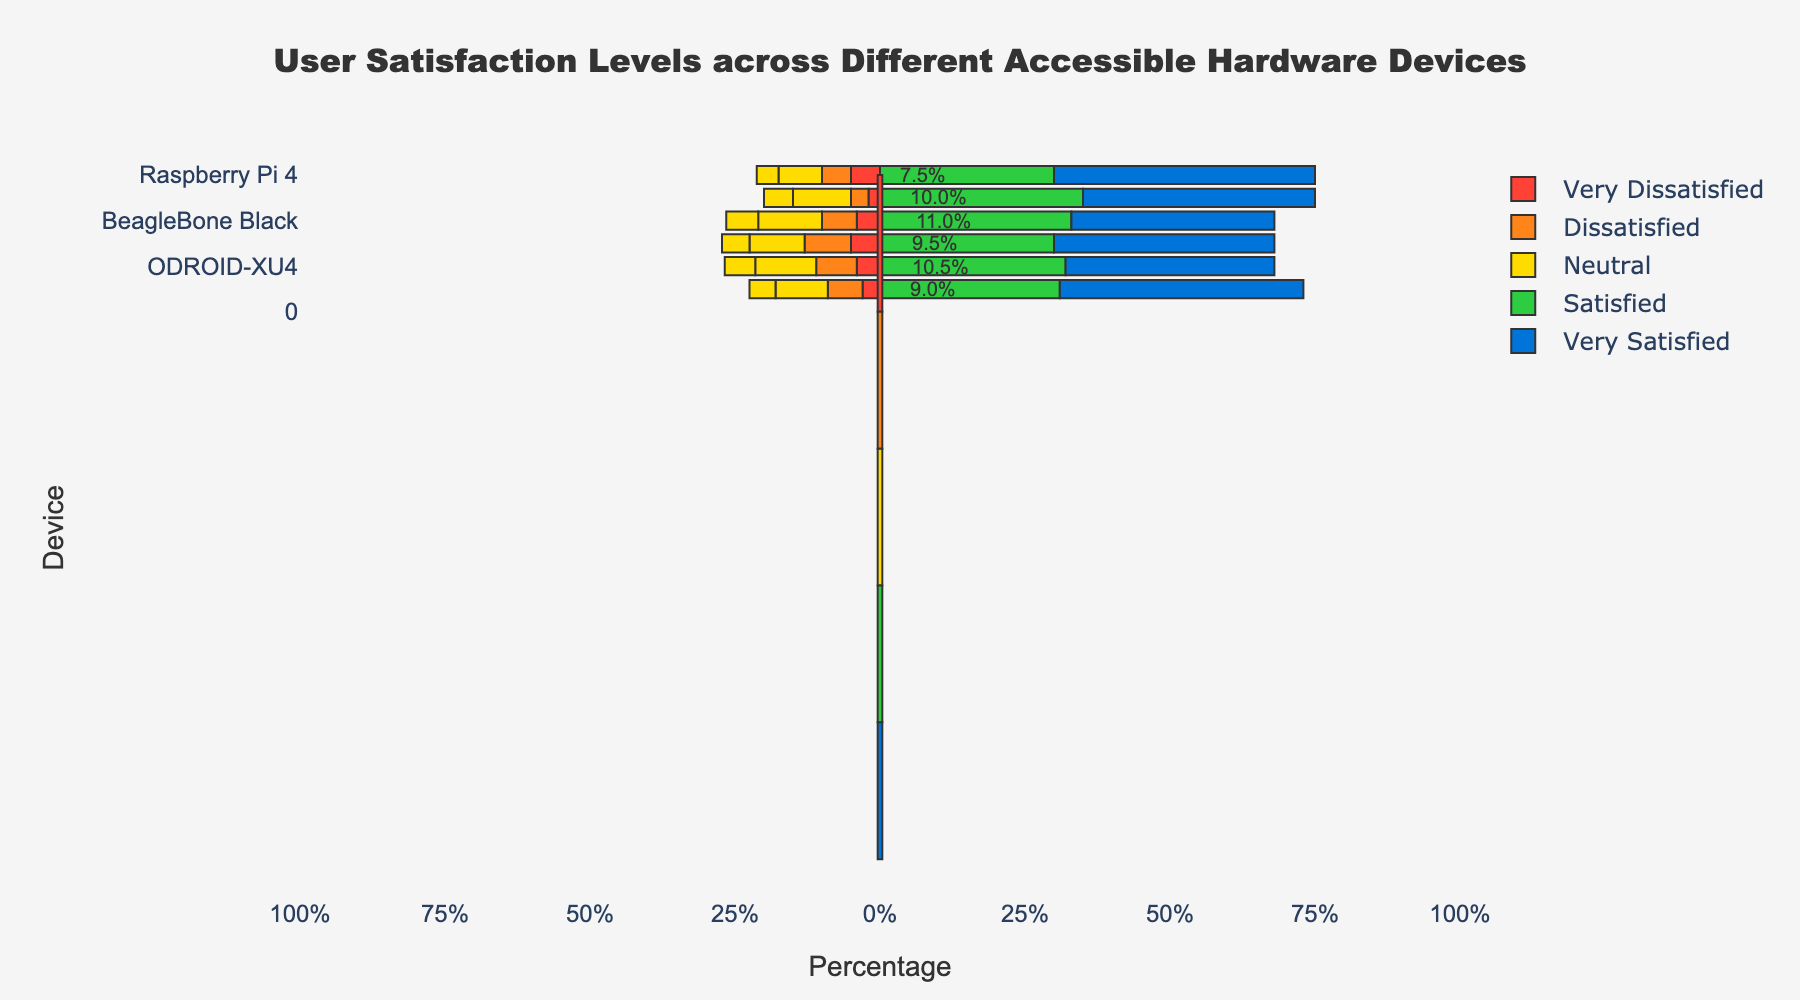Which device has the highest percentage of very satisfied users? To find the highest percentage of very satisfied users, look at the length of the blue bars for each device. The Raspberry Pi 4 has the longest blue bar indicating the highest percentage of very satisfied users.
Answer: Raspberry Pi 4 Compare the satisfaction levels (Very Satisfied + Satisfied) of Arduino Uno and Jetson Nano. Which one is higher? Add the percentages of very satisfied and satisfied users for both devices. Arduino Uno: Very Satisfied (40%) + Satisfied (35%) = 75%. Jetson Nano: Very Satisfied (42%) + Satisfied (31%) = 73%.
Answer: Arduino Uno What is the overall satisfaction (Very Satisfied + Satisfied) percentage for the Raspberry Pi 4 and BeagleBone Black combined? Add the percentages of very satisfied and satisfied users for both devices. Raspberry Pi 4: Very Satisfied (45%) + Satisfied (30%) = 75%. BeagleBone Black: Very Satisfied (35%) + Satisfied (33%) = 68%. Combined = 75% + 68% = 143%.
Answer: 143% Which device has the most neutral users? Identify the longest yellow bar representing neutral users. The BeagleBone Black has the longest yellow bar indicating the most neutral users.
Answer: BeagleBone Black What is the difference in the percentage of very dissatisfied users between Pinebook Pro and ODROID-XU4? Look at the length of the red bars for each device. Pinebook Pro: Very Dissatisfied (5%). ODROID-XU4: Very Dissatisfied (4%). Difference = 5% - 4% = 1%.
Answer: 1% Which two devices have the closest percentages of dissatisfied users? Compare the lengths of the orange bars indicating dissatisfied users. BeagleBone Black (6%) and Jetson Nano (6%) have the closest percentages.
Answer: BeagleBone Black and Jetson Nano Compare the levels of dissatisfaction (Dissatisfied + Very Dissatisfied) for the ODROID-XU4 and Raspberry Pi 4. Which one has higher levels of dissatisfaction? Add the percentages for dissatisfied and very dissatisfied users. ODROID-XU4: Dissatisfied (7%) + Very Dissatisfied (4%) = 11%. Raspberry Pi 4: Dissatisfied (5%) + Very Dissatisfied (5%) = 10%.
Answer: ODROID-XU4 What is the percentage range covered by the neutral users across all devices? Identify the minimum and maximum percentages for neutral users. Range spans from Arduino Uno (20%) to BeagleBone Black (22%).
Answer: 20% - 22% Calculate the percentage of dissatisfied and very dissatisfied users for all devices combined. Sum the percentages of dissatisfied and very dissatisfied users across all devices. Raspberry Pi 4: Dissatisfied (5%) + Very Dissatisfied (5%) = 10%. Arduino Uno: Dissatisfied (3%) + Very Dissatisfied (2%) = 5%. BeagleBone Black: Dissatisfied (6%) + Very Dissatisfied (4%) = 10%. Pinebook Pro: Dissatisfied (8%) + Very Dissatisfied (5%) = 13%. ODROID-XU4: Dissatisfied (7%) + Very Dissatisfied (4%) = 11%. Jetson Nano: Dissatisfied (6%) + Very Dissatisfied (3%) = 9%. Sum = 10% + 5% + 10% + 13% + 11% + 9% = 58%.
Answer: 58% Which device has the smallest gap between very satisfied and very dissatisfied percentages? Calculate the difference between very satisfied and very dissatisfied percentages for each device. Identify the smallest gap. For BeagleBone Black, the gap is 35% - 4% = 31%, which is the smallest.
Answer: BeagleBone Black 